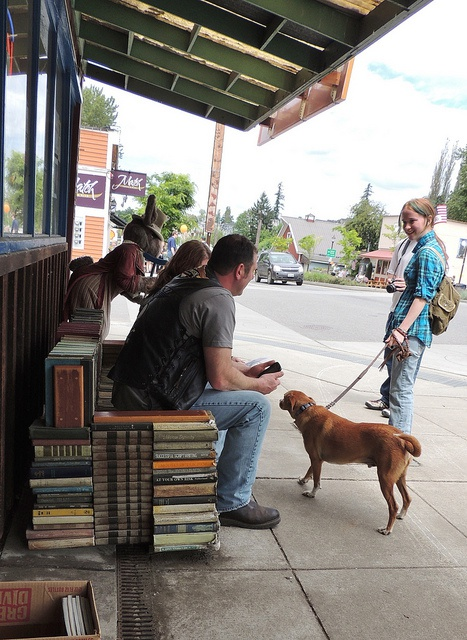Describe the objects in this image and their specific colors. I can see bench in black, gray, and maroon tones, book in black, gray, maroon, and darkgray tones, people in black, gray, darkgray, and brown tones, dog in black, maroon, and brown tones, and book in black and gray tones in this image. 